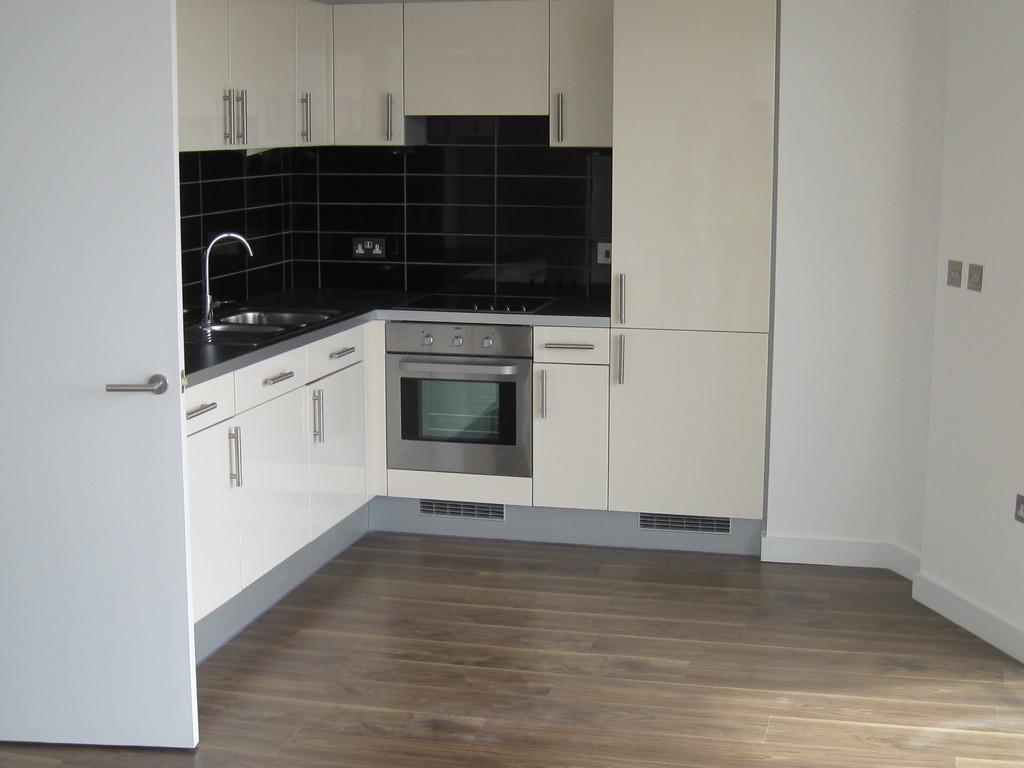What is located in the left corner of the image? There is a white door in the left corner of the image. What is situated beside the door? There is a wash basin beside the door. What is above the wash basin? There are cupboards above the wash basin. What is below the wash basin? There are cupboards below the wash basin. What type of tax is being discussed in the image? There is no discussion of tax in the image; it features a white door, a wash basin, and cupboards. Can you see a tin object in the image? There is no tin object present in the image. 